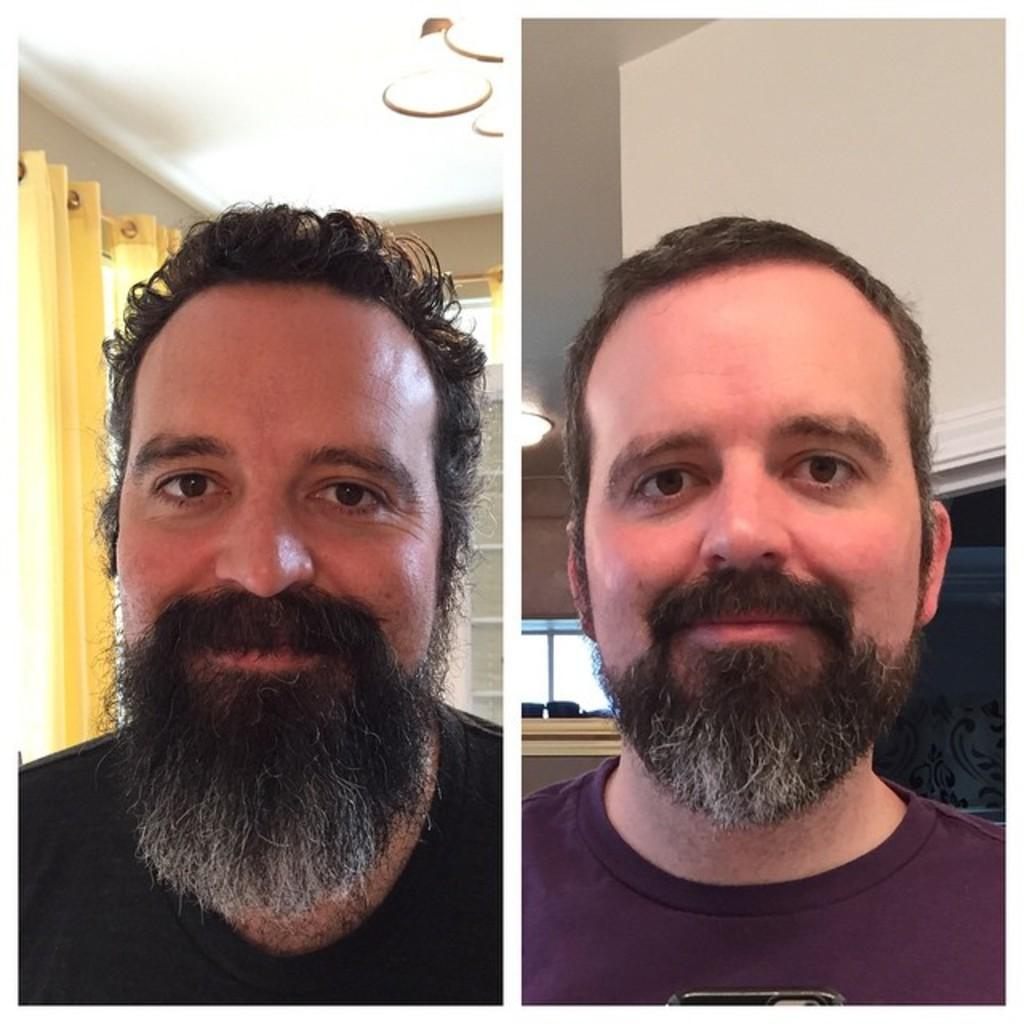What are the men in the image wearing? The men in the image are wearing t-shirts. What type of window treatment can be seen in the image? There are curtains in the image. Can you describe the lighting in the image? There is light visible in the image. What other objects can be seen in the image besides the men and curtains? There are unspecified objects in the image. What is the men's reaction to the loaf of bread in the image? There is no loaf of bread present in the image, so it is not possible to determine the men's reaction to it. 